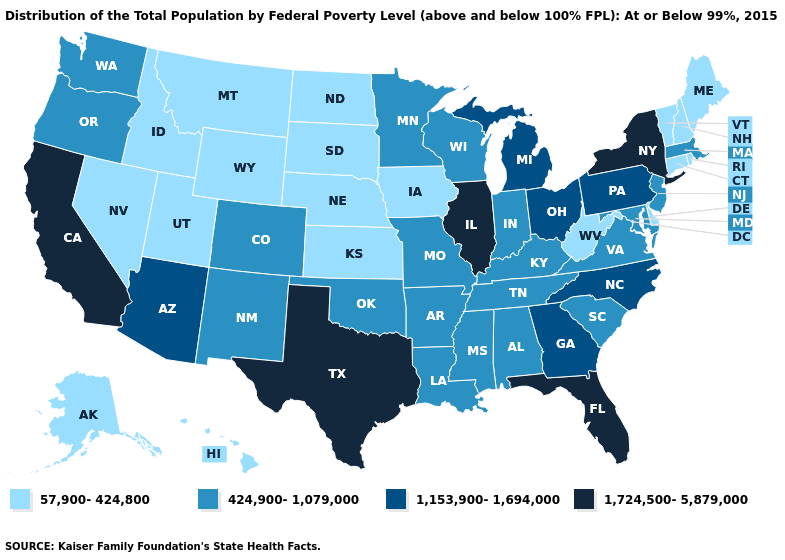Does Mississippi have the highest value in the USA?
Quick response, please. No. Among the states that border New Jersey , which have the highest value?
Write a very short answer. New York. What is the value of Virginia?
Write a very short answer. 424,900-1,079,000. Among the states that border Mississippi , which have the lowest value?
Write a very short answer. Alabama, Arkansas, Louisiana, Tennessee. Name the states that have a value in the range 1,153,900-1,694,000?
Short answer required. Arizona, Georgia, Michigan, North Carolina, Ohio, Pennsylvania. What is the value of Nebraska?
Answer briefly. 57,900-424,800. Name the states that have a value in the range 1,153,900-1,694,000?
Be succinct. Arizona, Georgia, Michigan, North Carolina, Ohio, Pennsylvania. What is the highest value in states that border Illinois?
Answer briefly. 424,900-1,079,000. Among the states that border Colorado , does Oklahoma have the highest value?
Short answer required. No. What is the value of Maine?
Short answer required. 57,900-424,800. What is the value of Arizona?
Write a very short answer. 1,153,900-1,694,000. What is the value of Washington?
Answer briefly. 424,900-1,079,000. What is the value of Montana?
Quick response, please. 57,900-424,800. What is the value of Montana?
Short answer required. 57,900-424,800. 